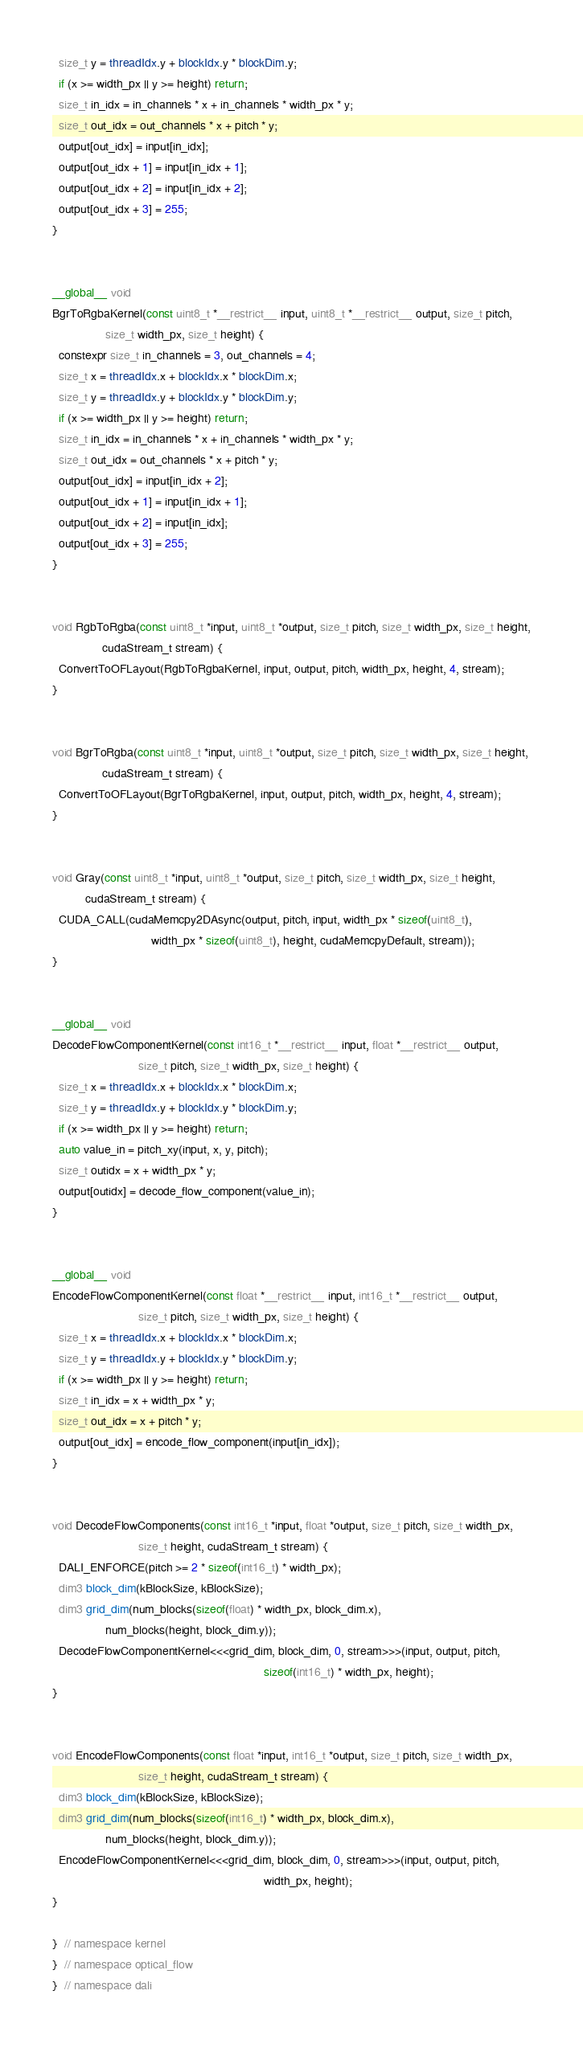Convert code to text. <code><loc_0><loc_0><loc_500><loc_500><_Cuda_>  size_t y = threadIdx.y + blockIdx.y * blockDim.y;
  if (x >= width_px || y >= height) return;
  size_t in_idx = in_channels * x + in_channels * width_px * y;
  size_t out_idx = out_channels * x + pitch * y;
  output[out_idx] = input[in_idx];
  output[out_idx + 1] = input[in_idx + 1];
  output[out_idx + 2] = input[in_idx + 2];
  output[out_idx + 3] = 255;
}


__global__ void
BgrToRgbaKernel(const uint8_t *__restrict__ input, uint8_t *__restrict__ output, size_t pitch,
                size_t width_px, size_t height) {
  constexpr size_t in_channels = 3, out_channels = 4;
  size_t x = threadIdx.x + blockIdx.x * blockDim.x;
  size_t y = threadIdx.y + blockIdx.y * blockDim.y;
  if (x >= width_px || y >= height) return;
  size_t in_idx = in_channels * x + in_channels * width_px * y;
  size_t out_idx = out_channels * x + pitch * y;
  output[out_idx] = input[in_idx + 2];
  output[out_idx + 1] = input[in_idx + 1];
  output[out_idx + 2] = input[in_idx];
  output[out_idx + 3] = 255;
}


void RgbToRgba(const uint8_t *input, uint8_t *output, size_t pitch, size_t width_px, size_t height,
               cudaStream_t stream) {
  ConvertToOFLayout(RgbToRgbaKernel, input, output, pitch, width_px, height, 4, stream);
}


void BgrToRgba(const uint8_t *input, uint8_t *output, size_t pitch, size_t width_px, size_t height,
               cudaStream_t stream) {
  ConvertToOFLayout(BgrToRgbaKernel, input, output, pitch, width_px, height, 4, stream);
}


void Gray(const uint8_t *input, uint8_t *output, size_t pitch, size_t width_px, size_t height,
          cudaStream_t stream) {
  CUDA_CALL(cudaMemcpy2DAsync(output, pitch, input, width_px * sizeof(uint8_t),
                              width_px * sizeof(uint8_t), height, cudaMemcpyDefault, stream));
}


__global__ void
DecodeFlowComponentKernel(const int16_t *__restrict__ input, float *__restrict__ output,
                          size_t pitch, size_t width_px, size_t height) {
  size_t x = threadIdx.x + blockIdx.x * blockDim.x;
  size_t y = threadIdx.y + blockIdx.y * blockDim.y;
  if (x >= width_px || y >= height) return;
  auto value_in = pitch_xy(input, x, y, pitch);
  size_t outidx = x + width_px * y;
  output[outidx] = decode_flow_component(value_in);
}


__global__ void
EncodeFlowComponentKernel(const float *__restrict__ input, int16_t *__restrict__ output,
                          size_t pitch, size_t width_px, size_t height) {
  size_t x = threadIdx.x + blockIdx.x * blockDim.x;
  size_t y = threadIdx.y + blockIdx.y * blockDim.y;
  if (x >= width_px || y >= height) return;
  size_t in_idx = x + width_px * y;
  size_t out_idx = x + pitch * y;
  output[out_idx] = encode_flow_component(input[in_idx]);
}


void DecodeFlowComponents(const int16_t *input, float *output, size_t pitch, size_t width_px,
                          size_t height, cudaStream_t stream) {
  DALI_ENFORCE(pitch >= 2 * sizeof(int16_t) * width_px);
  dim3 block_dim(kBlockSize, kBlockSize);
  dim3 grid_dim(num_blocks(sizeof(float) * width_px, block_dim.x),
                num_blocks(height, block_dim.y));
  DecodeFlowComponentKernel<<<grid_dim, block_dim, 0, stream>>>(input, output, pitch,
                                                                sizeof(int16_t) * width_px, height);
}


void EncodeFlowComponents(const float *input, int16_t *output, size_t pitch, size_t width_px,
                          size_t height, cudaStream_t stream) {
  dim3 block_dim(kBlockSize, kBlockSize);
  dim3 grid_dim(num_blocks(sizeof(int16_t) * width_px, block_dim.x),
                num_blocks(height, block_dim.y));
  EncodeFlowComponentKernel<<<grid_dim, block_dim, 0, stream>>>(input, output, pitch,
                                                                width_px, height);
}

}  // namespace kernel
}  // namespace optical_flow
}  // namespace dali
</code> 